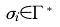<formula> <loc_0><loc_0><loc_500><loc_500>\sigma _ { i } \in \Gamma ^ { * }</formula> 